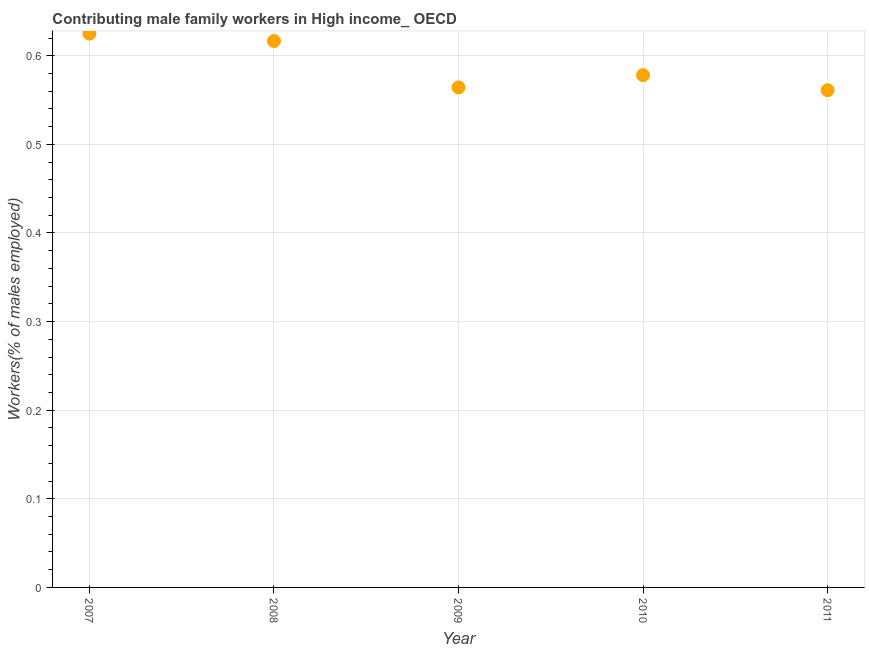What is the contributing male family workers in 2009?
Your response must be concise. 0.56. Across all years, what is the maximum contributing male family workers?
Provide a short and direct response. 0.62. Across all years, what is the minimum contributing male family workers?
Offer a very short reply. 0.56. In which year was the contributing male family workers maximum?
Your answer should be very brief. 2007. What is the sum of the contributing male family workers?
Your answer should be very brief. 2.95. What is the difference between the contributing male family workers in 2007 and 2011?
Ensure brevity in your answer.  0.06. What is the average contributing male family workers per year?
Your response must be concise. 0.59. What is the median contributing male family workers?
Your response must be concise. 0.58. Do a majority of the years between 2011 and 2008 (inclusive) have contributing male family workers greater than 0.54 %?
Your answer should be compact. Yes. What is the ratio of the contributing male family workers in 2009 to that in 2011?
Offer a terse response. 1.01. Is the difference between the contributing male family workers in 2008 and 2011 greater than the difference between any two years?
Your response must be concise. No. What is the difference between the highest and the second highest contributing male family workers?
Your answer should be compact. 0.01. Is the sum of the contributing male family workers in 2009 and 2010 greater than the maximum contributing male family workers across all years?
Your response must be concise. Yes. What is the difference between the highest and the lowest contributing male family workers?
Offer a very short reply. 0.06. In how many years, is the contributing male family workers greater than the average contributing male family workers taken over all years?
Provide a short and direct response. 2. Are the values on the major ticks of Y-axis written in scientific E-notation?
Keep it short and to the point. No. Does the graph contain any zero values?
Ensure brevity in your answer.  No. What is the title of the graph?
Keep it short and to the point. Contributing male family workers in High income_ OECD. What is the label or title of the X-axis?
Keep it short and to the point. Year. What is the label or title of the Y-axis?
Offer a terse response. Workers(% of males employed). What is the Workers(% of males employed) in 2007?
Ensure brevity in your answer.  0.62. What is the Workers(% of males employed) in 2008?
Offer a terse response. 0.62. What is the Workers(% of males employed) in 2009?
Provide a short and direct response. 0.56. What is the Workers(% of males employed) in 2010?
Your answer should be very brief. 0.58. What is the Workers(% of males employed) in 2011?
Provide a succinct answer. 0.56. What is the difference between the Workers(% of males employed) in 2007 and 2008?
Give a very brief answer. 0.01. What is the difference between the Workers(% of males employed) in 2007 and 2009?
Keep it short and to the point. 0.06. What is the difference between the Workers(% of males employed) in 2007 and 2010?
Provide a succinct answer. 0.05. What is the difference between the Workers(% of males employed) in 2007 and 2011?
Your response must be concise. 0.06. What is the difference between the Workers(% of males employed) in 2008 and 2009?
Keep it short and to the point. 0.05. What is the difference between the Workers(% of males employed) in 2008 and 2010?
Keep it short and to the point. 0.04. What is the difference between the Workers(% of males employed) in 2008 and 2011?
Provide a succinct answer. 0.06. What is the difference between the Workers(% of males employed) in 2009 and 2010?
Provide a succinct answer. -0.01. What is the difference between the Workers(% of males employed) in 2009 and 2011?
Your answer should be compact. 0. What is the difference between the Workers(% of males employed) in 2010 and 2011?
Offer a terse response. 0.02. What is the ratio of the Workers(% of males employed) in 2007 to that in 2008?
Provide a short and direct response. 1.01. What is the ratio of the Workers(% of males employed) in 2007 to that in 2009?
Your answer should be compact. 1.11. What is the ratio of the Workers(% of males employed) in 2007 to that in 2010?
Your response must be concise. 1.08. What is the ratio of the Workers(% of males employed) in 2007 to that in 2011?
Give a very brief answer. 1.11. What is the ratio of the Workers(% of males employed) in 2008 to that in 2009?
Ensure brevity in your answer.  1.09. What is the ratio of the Workers(% of males employed) in 2008 to that in 2010?
Offer a very short reply. 1.07. What is the ratio of the Workers(% of males employed) in 2008 to that in 2011?
Ensure brevity in your answer.  1.1. What is the ratio of the Workers(% of males employed) in 2009 to that in 2010?
Provide a succinct answer. 0.98. What is the ratio of the Workers(% of males employed) in 2009 to that in 2011?
Give a very brief answer. 1.01. 